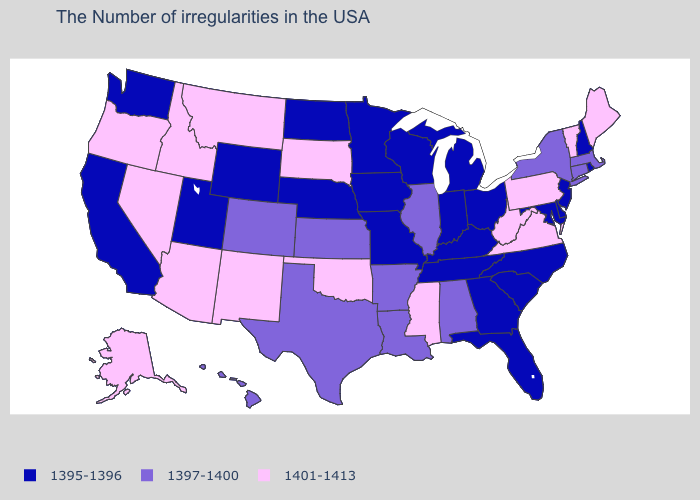Name the states that have a value in the range 1401-1413?
Answer briefly. Maine, Vermont, Pennsylvania, Virginia, West Virginia, Mississippi, Oklahoma, South Dakota, New Mexico, Montana, Arizona, Idaho, Nevada, Oregon, Alaska. What is the lowest value in the South?
Answer briefly. 1395-1396. How many symbols are there in the legend?
Keep it brief. 3. What is the highest value in the USA?
Keep it brief. 1401-1413. Is the legend a continuous bar?
Write a very short answer. No. Is the legend a continuous bar?
Concise answer only. No. What is the value of Hawaii?
Concise answer only. 1397-1400. What is the lowest value in the West?
Give a very brief answer. 1395-1396. Does Oregon have the highest value in the USA?
Concise answer only. Yes. Name the states that have a value in the range 1401-1413?
Quick response, please. Maine, Vermont, Pennsylvania, Virginia, West Virginia, Mississippi, Oklahoma, South Dakota, New Mexico, Montana, Arizona, Idaho, Nevada, Oregon, Alaska. What is the value of Rhode Island?
Short answer required. 1395-1396. What is the highest value in states that border Wisconsin?
Keep it brief. 1397-1400. What is the highest value in the West ?
Quick response, please. 1401-1413. 